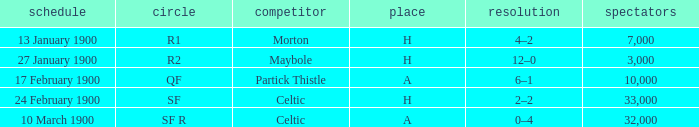How many people attended in the game against morton? 7000.0. 